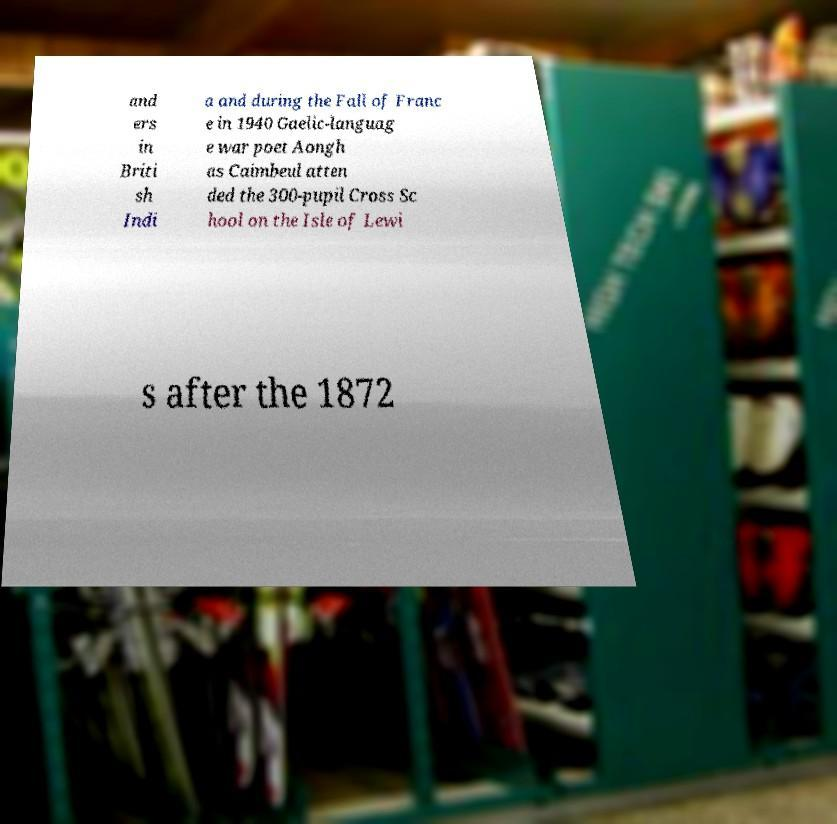There's text embedded in this image that I need extracted. Can you transcribe it verbatim? and ers in Briti sh Indi a and during the Fall of Franc e in 1940 Gaelic-languag e war poet Aongh as Caimbeul atten ded the 300-pupil Cross Sc hool on the Isle of Lewi s after the 1872 